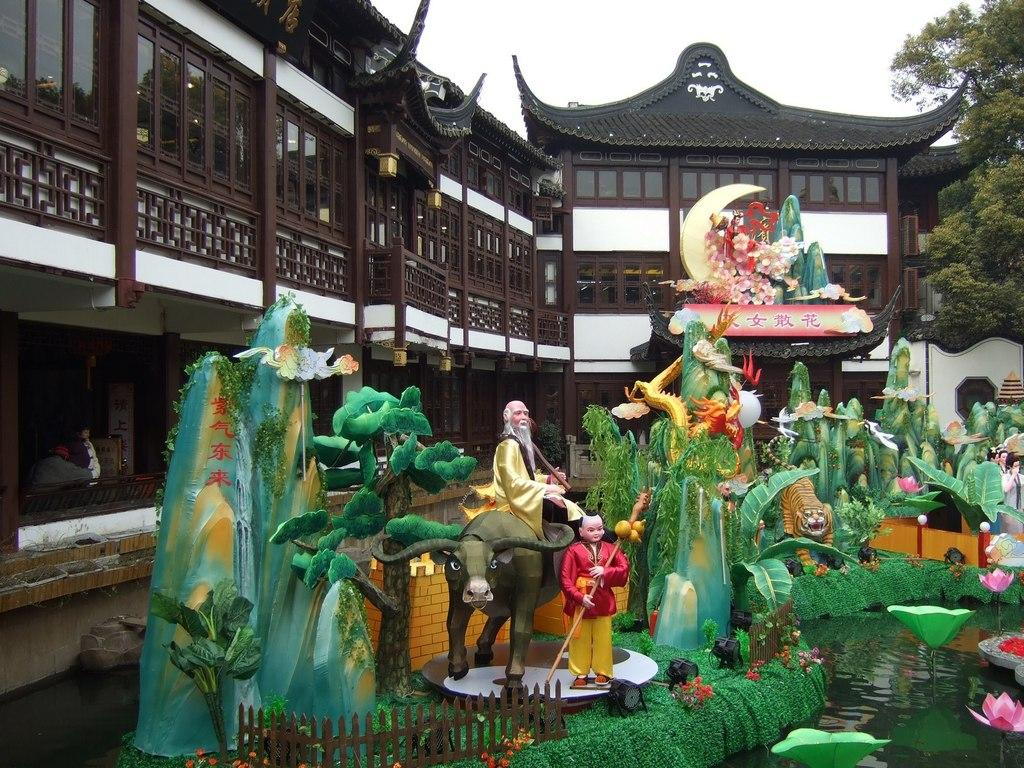What is on the water surface in the image? There are sculptures on the water surface in the image. What can be seen in the background of the image? There is a building and a tree visible in the background. What type of chin can be seen on the beggar in the image? There is no beggar present in the image, and therefore no chin to describe. What is the beggar using to collect coins in the image? There is no beggar or pan present in the image. 